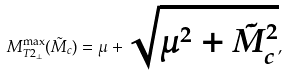Convert formula to latex. <formula><loc_0><loc_0><loc_500><loc_500>M _ { T 2 _ { \perp } } ^ { \max } ( \tilde { M } _ { c } ) = \mu + \sqrt { \mu ^ { 2 } + \tilde { M } _ { c } ^ { 2 } } ,</formula> 